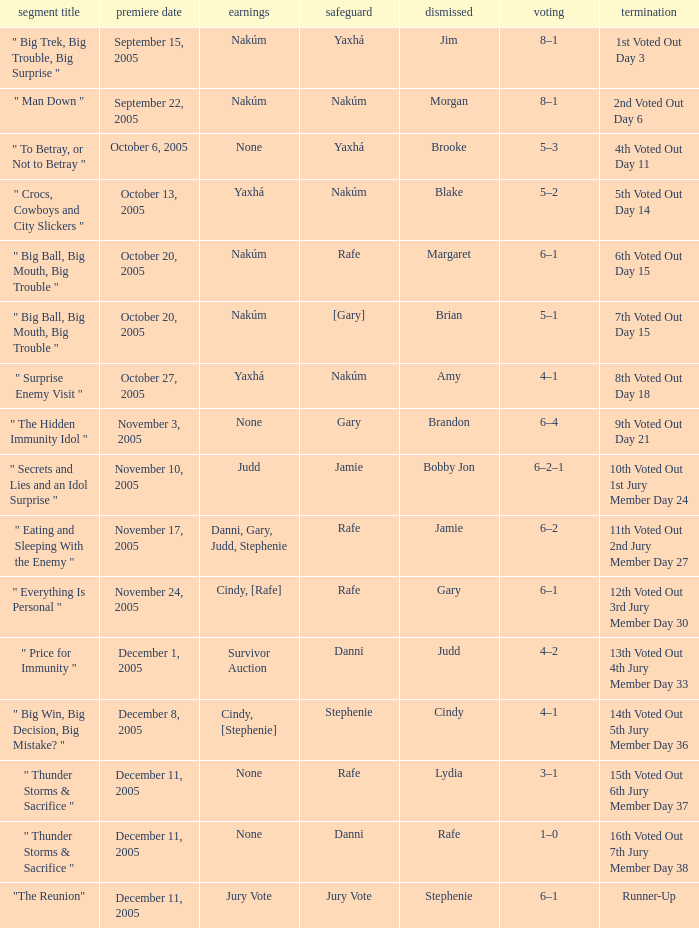How many air dates were there when Morgan was eliminated? 1.0. 